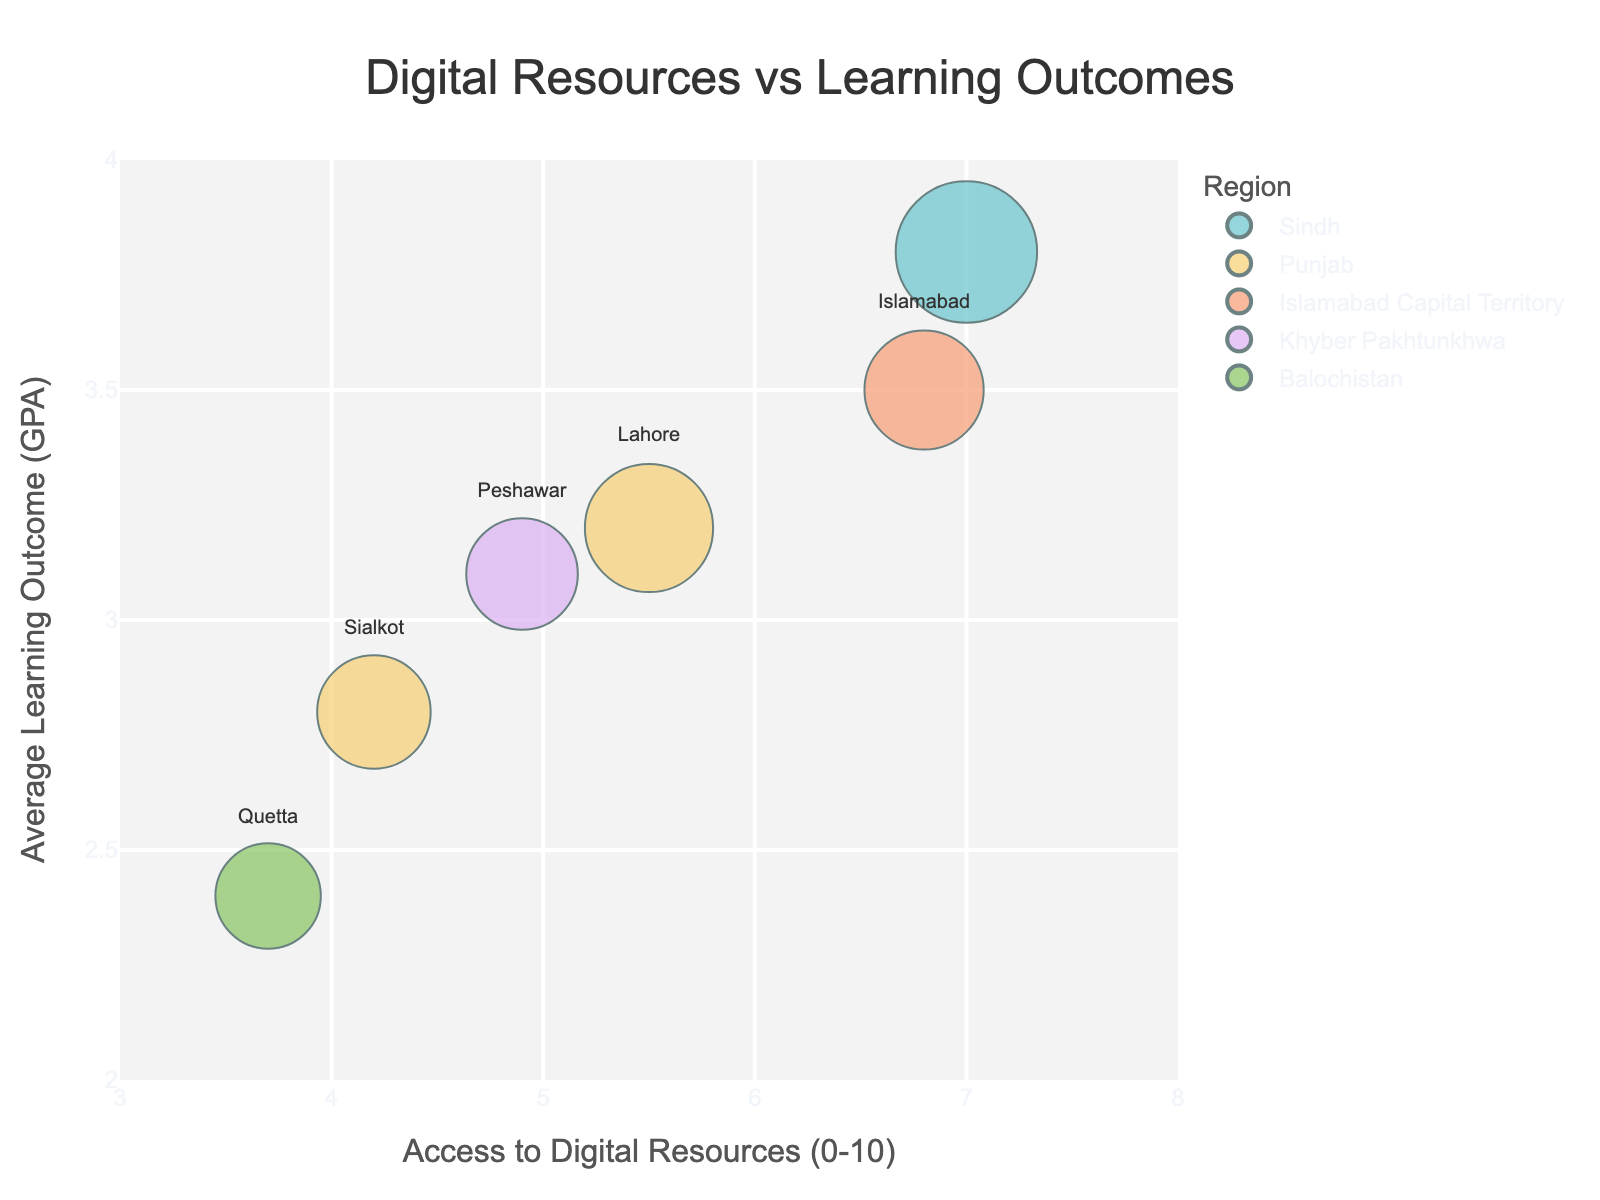How many schools are represented in the figure? The figure uses bubbles to represent different schools. Count the bubbles to find the number of schools.
Answer: 6 Which school has the highest average learning outcome (GPA)? Look at the y-axis (Average Learning Outcome (GPA)) and identify the bubble that is highest on the plot. Hover over this bubble and find the school in the popup.
Answer: Hillview High School What is the access to digital resources rating for Green Valley Academy? Find the bubble for Green Valley Academy either by looking at the city labels or by hovering over the bubbles. Then find the x-axis value for this bubble.
Answer: 5.5 Compare the access to digital resources between Unity Secondary School and Modern Girls School. Which one has higher access? Identify the bubbles for Unity Secondary School and Modern Girls School by their city labels or hovering over them. Compare their x-axis positions (Access to Digital Resources (0-10)).
Answer: Modern Girls School What can you infer about the relationship between access to digital resources and average learning outcome from the plotted data? Observe the general trend of the bubbles in the plot. As the value on the x-axis (Access to Digital Resources (0-10)) increases, check if the position on the y-axis (Average Learning Outcome (GPA)) also tends to increase.
Answer: Higher access to digital resources seems to correlate with higher learning outcomes What is the size of the bubble representing Hillview High School? Find the bubble for Hillview High School and note the size which corresponds to the number of students.
Answer: 450 Which city has the most students represented in the figure and which school does it correspond to? Size of bubble indicates number of students. Identify the largest bubble and note the corresponding city and school.
Answer: Karachi, Hillview High School Calculate the average GPA of schools located in Punjab. Identify and note the GPA for schools in Punjab: Green Valley Academy and Modern Girls School. Calculate the average: (3.2 + 2.8) / 2 = 3.0
Answer: 3.0 Compare the schools in Sindh and Balochistan. Which has a better average learning outcome? Identify schools in Sindh (Hillview High School) and Balochistan (Unity Secondary School). Compare their GPA values: 3.8 (Sindh) vs 2.4 (Balochistan).
Answer: Sindh Describe the correlation between bubble size (number of students) and average learning outcome (GPA) in this figure. Observe if larger or smaller bubbles tend to be higher or lower on the y-axis, indicating whether there's a pattern in student number and learning outcomes.
Answer: No clear correlation 